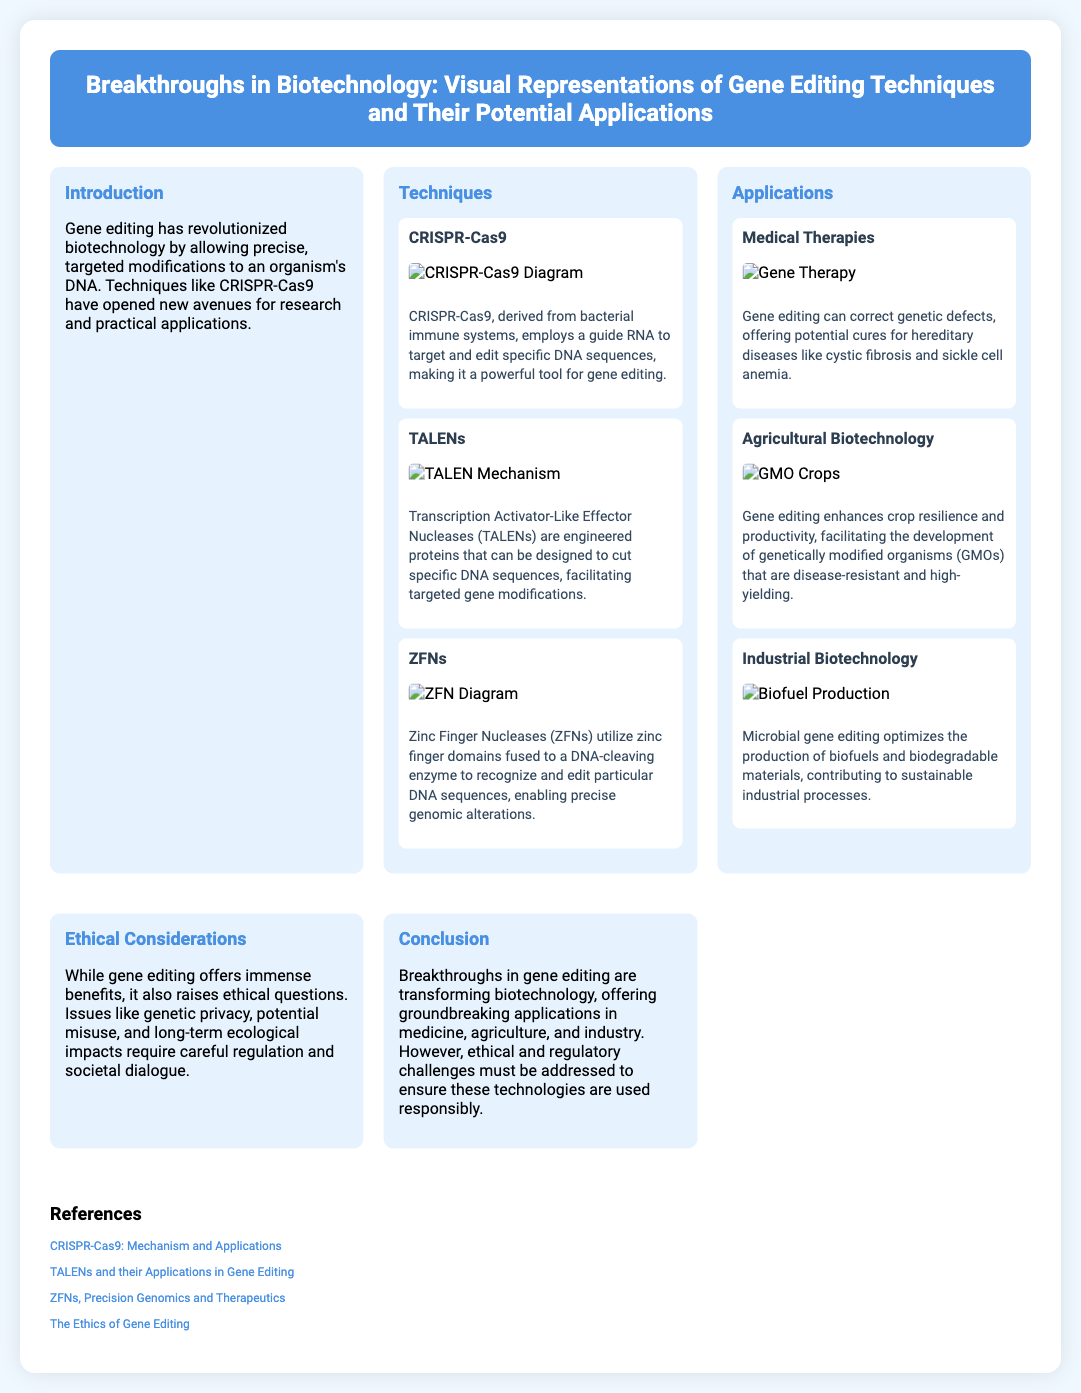What is the title of the poster? The title is displayed prominently at the top of the poster, summarizing the main topic covered.
Answer: Breakthroughs in Biotechnology: Visual Representations of Gene Editing Techniques and Their Potential Applications What technique uses a guide RNA for DNA editing? The section discussing gene editing techniques specifies that CRISPR-Cas9 employs this method.
Answer: CRISPR-Cas9 What are TALENs designed to do? The TALENs subsection explains that these proteins are engineered to cut specific DNA sequences.
Answer: Cut specific DNA sequences Which hereditary disease can gene editing potentially cure? In the medical therapies section, cystic fibrosis is mentioned as a specific example.
Answer: Cystic fibrosis What is one application of gene editing in agriculture? The agricultural biotechnology section details that gene editing enhances crop resilience and productivity.
Answer: Enhances crop resilience and productivity What ethical issues does gene editing raise? The ethical considerations section outlines concerns such as genetic privacy and potential misuse.
Answer: Genetic privacy How many main techniques are listed in the poster? The techniques section lists three main gene editing techniques.
Answer: Three What type of biotechnology involves optimizing biofuel production? The industrial biotechnology subsection specifically addresses the optimization of biofuels.
Answer: Industrial Biotechnology Where can more information about the ethics of gene editing be found? The references section includes a link to a source discussing this topic in detail.
Answer: The Ethics of Gene Editing 